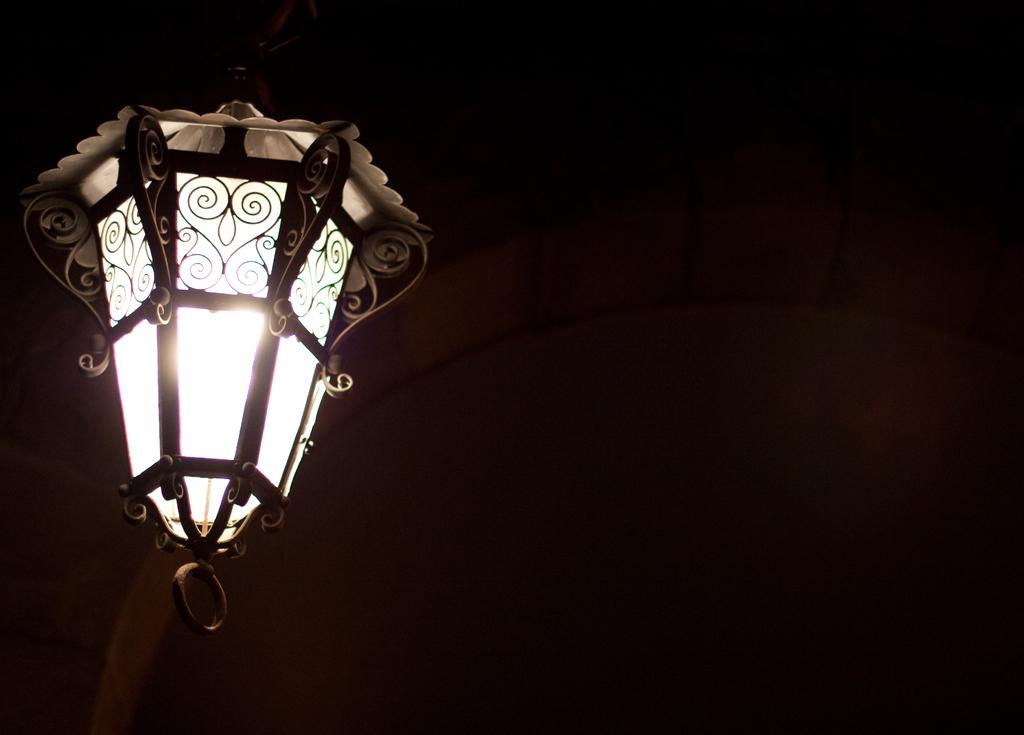What can be seen on the left side of the image? There is a light on the left side of the image. What is visible in the background of the image? There is a wall in the background of the image. What type of watch is the son wearing in the image? There is no son or watch present in the image. 